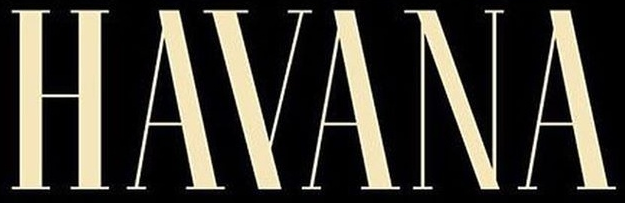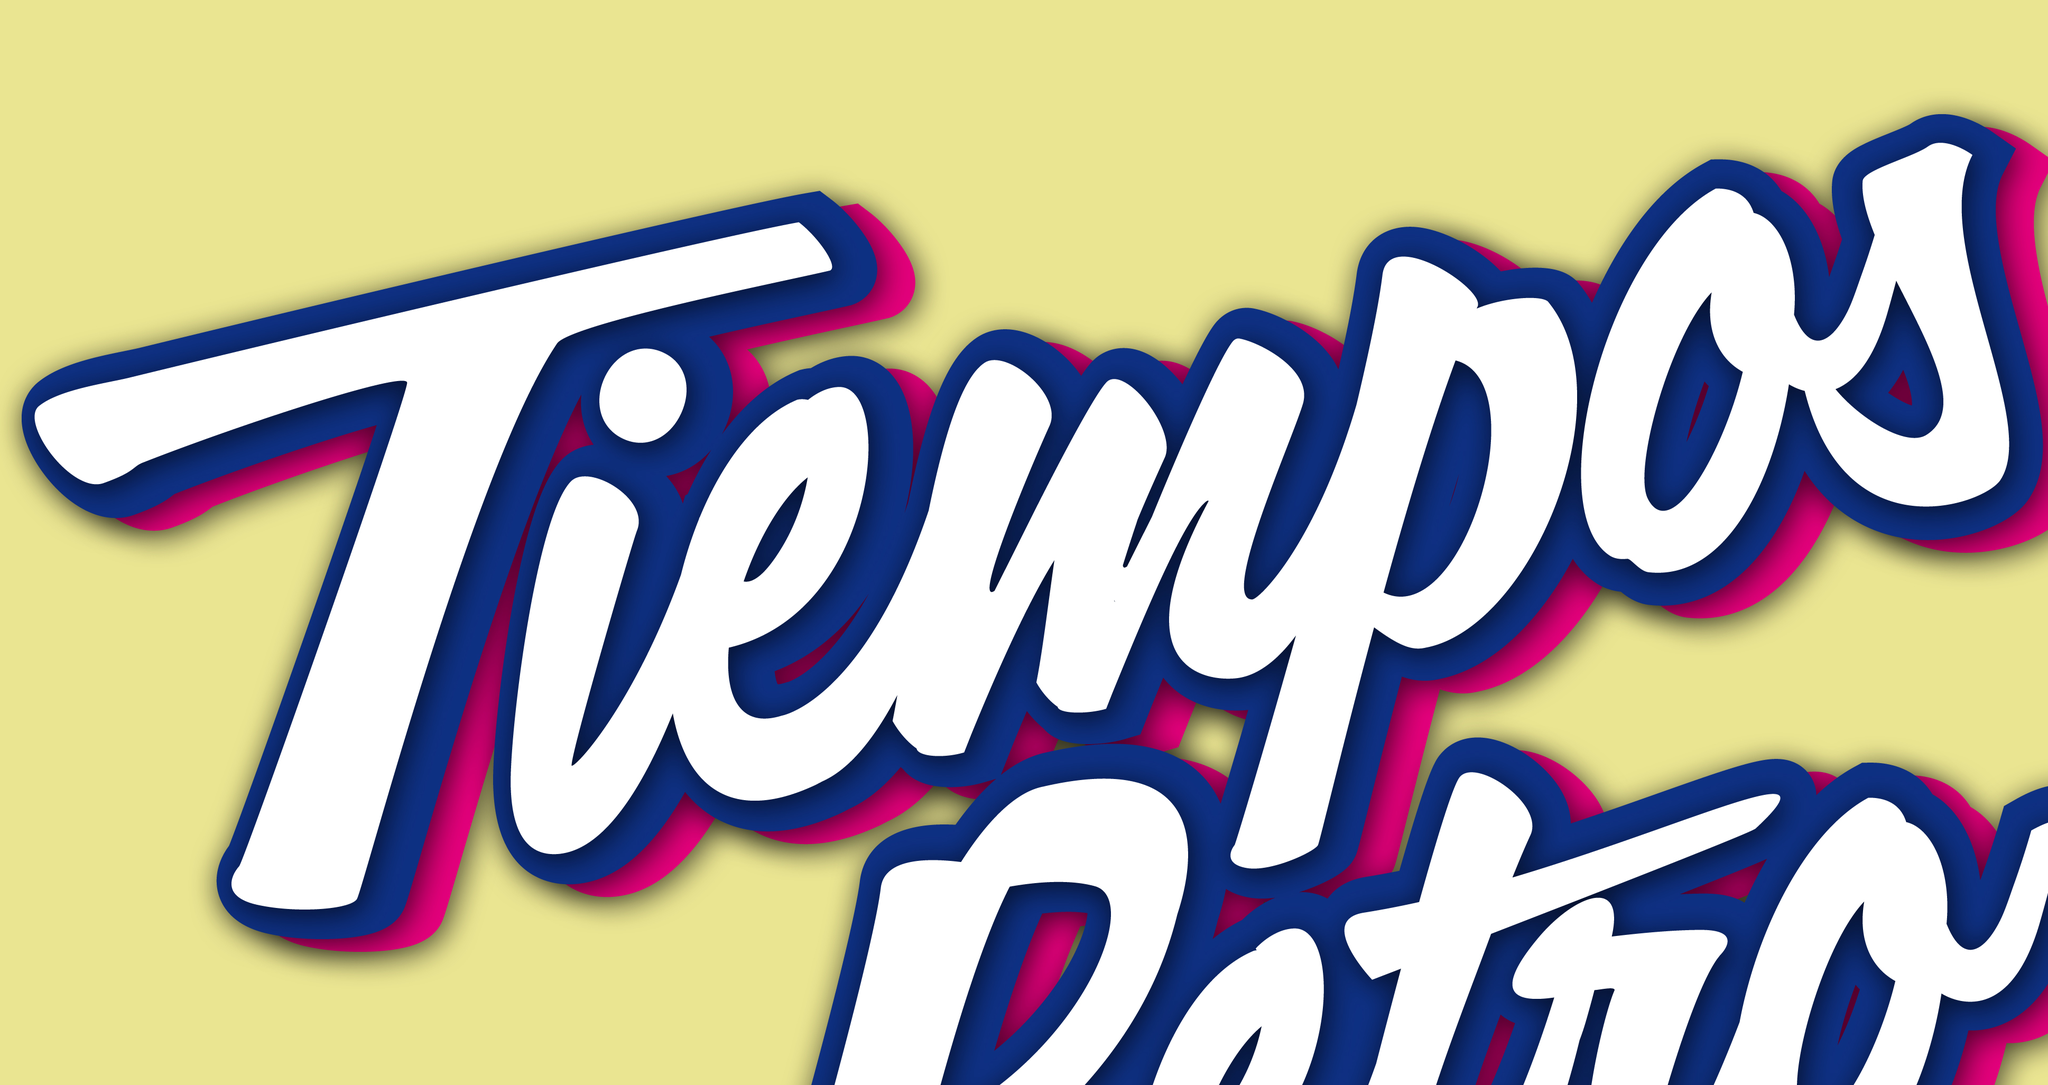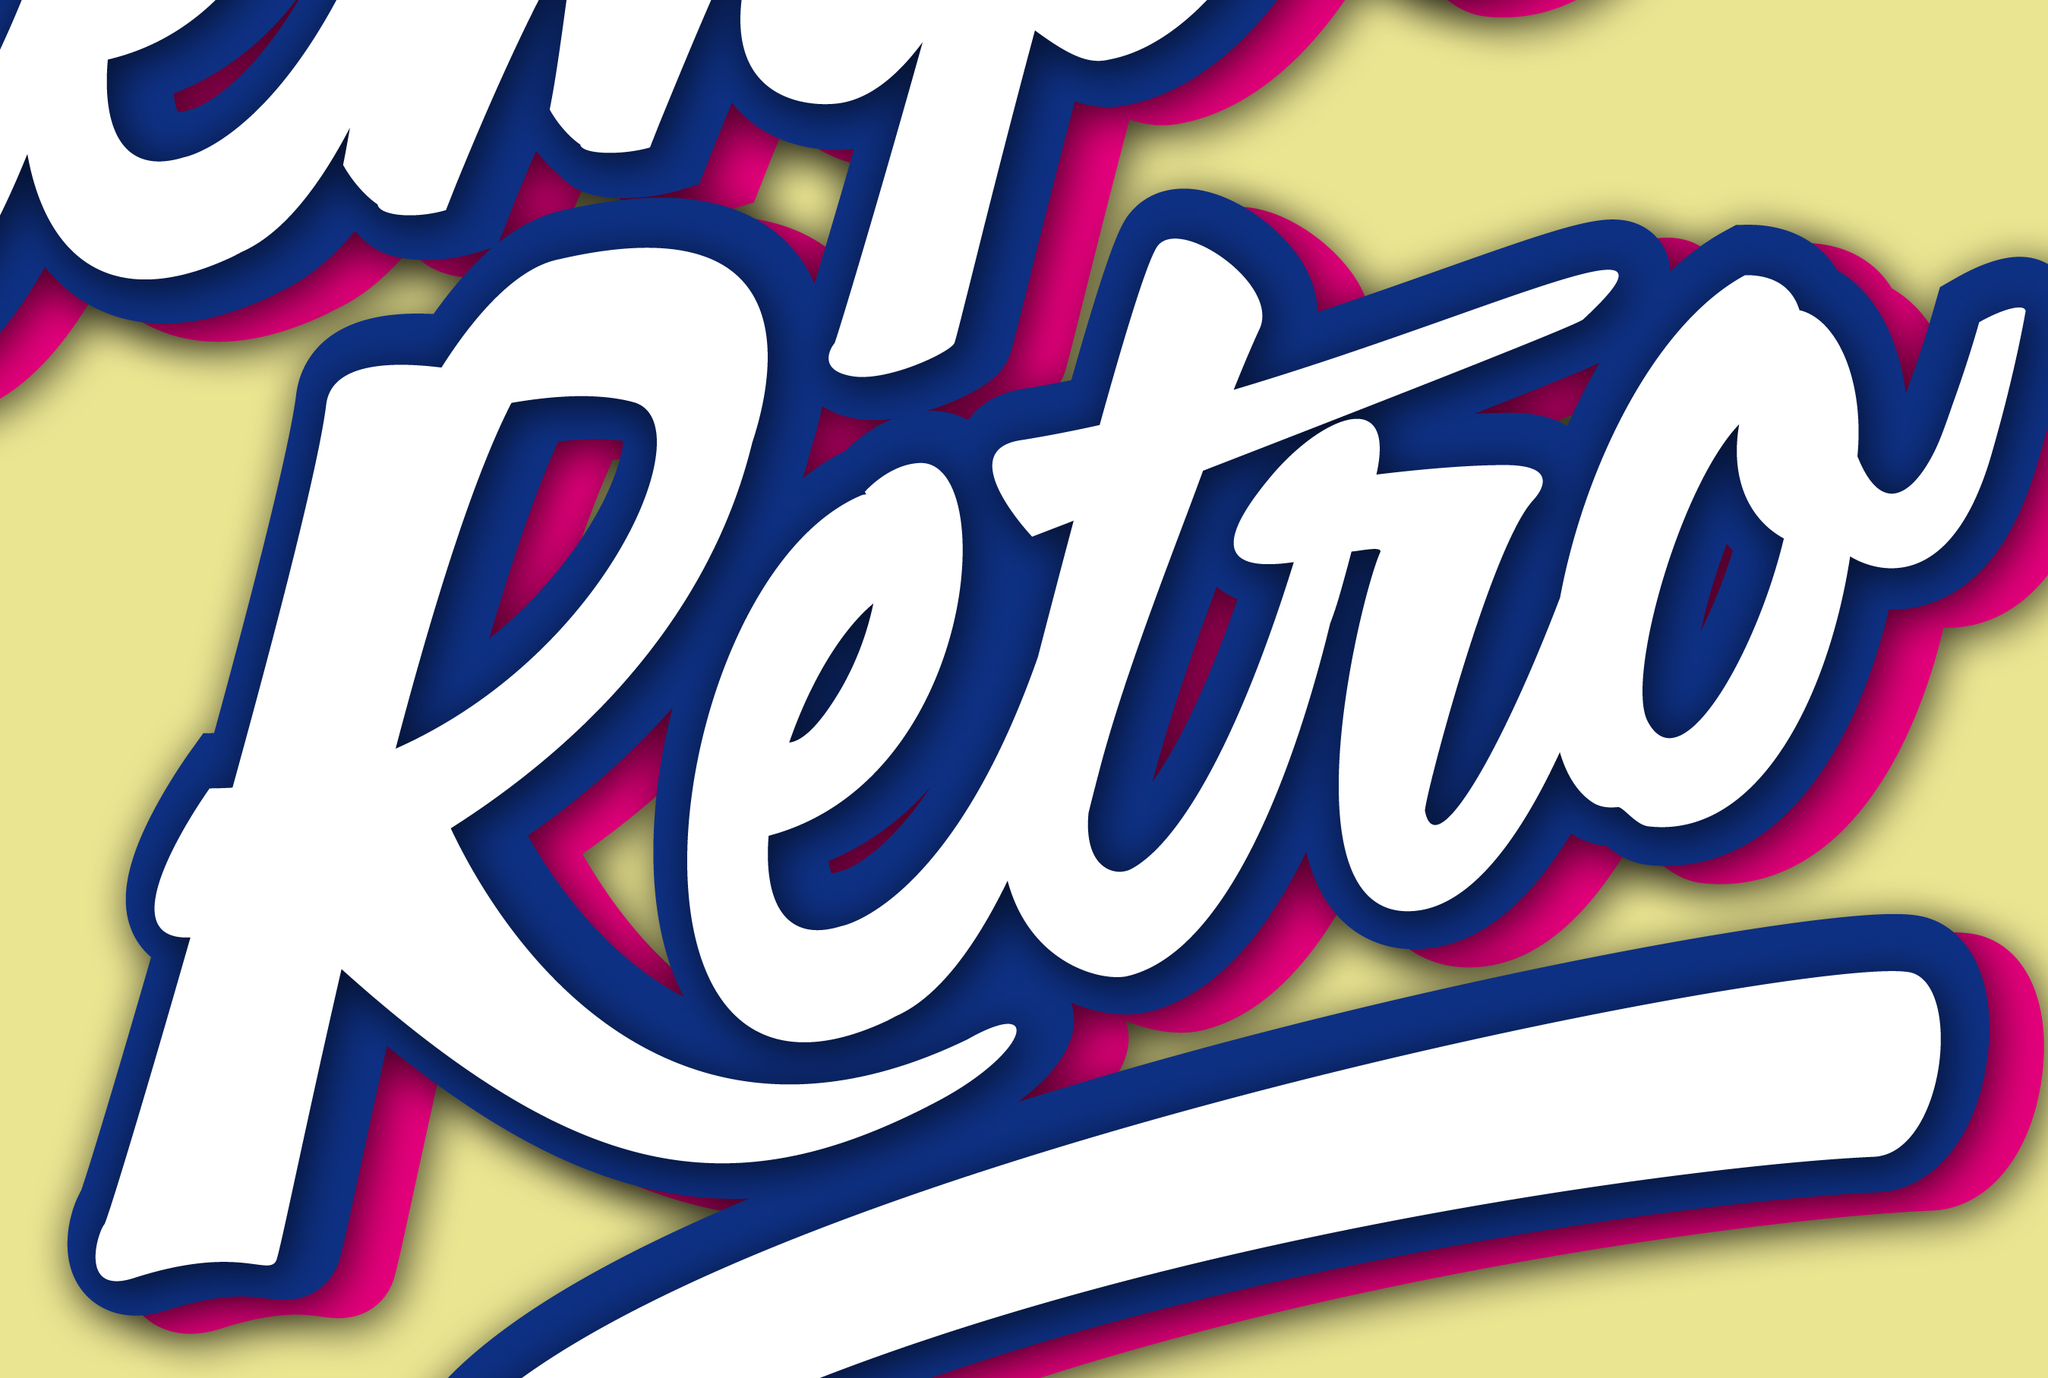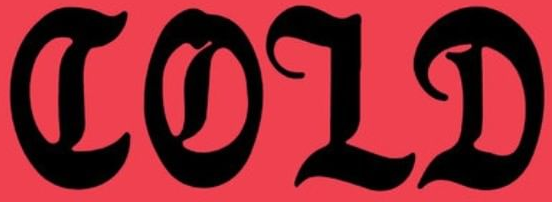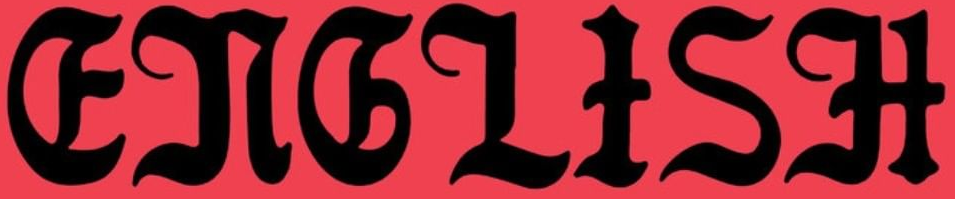Identify the words shown in these images in order, separated by a semicolon. HAYANA; Tiempos; Retro; COLD; ENGLISH 